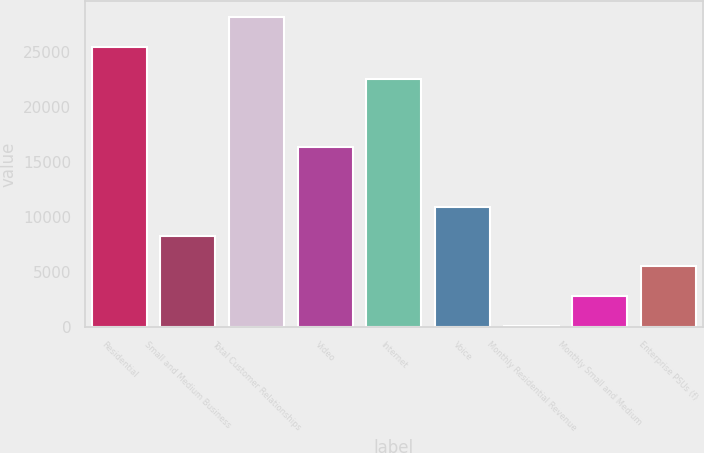Convert chart to OTSL. <chart><loc_0><loc_0><loc_500><loc_500><bar_chart><fcel>Residential<fcel>Small and Medium Business<fcel>Total Customer Relationships<fcel>Video<fcel>Internet<fcel>Voice<fcel>Monthly Residential Revenue<fcel>Monthly Small and Medium<fcel>Enterprise PSUs (f)<nl><fcel>25499<fcel>8225.49<fcel>28204.1<fcel>16400<fcel>22518<fcel>10930.6<fcel>110.28<fcel>2815.35<fcel>5520.42<nl></chart> 